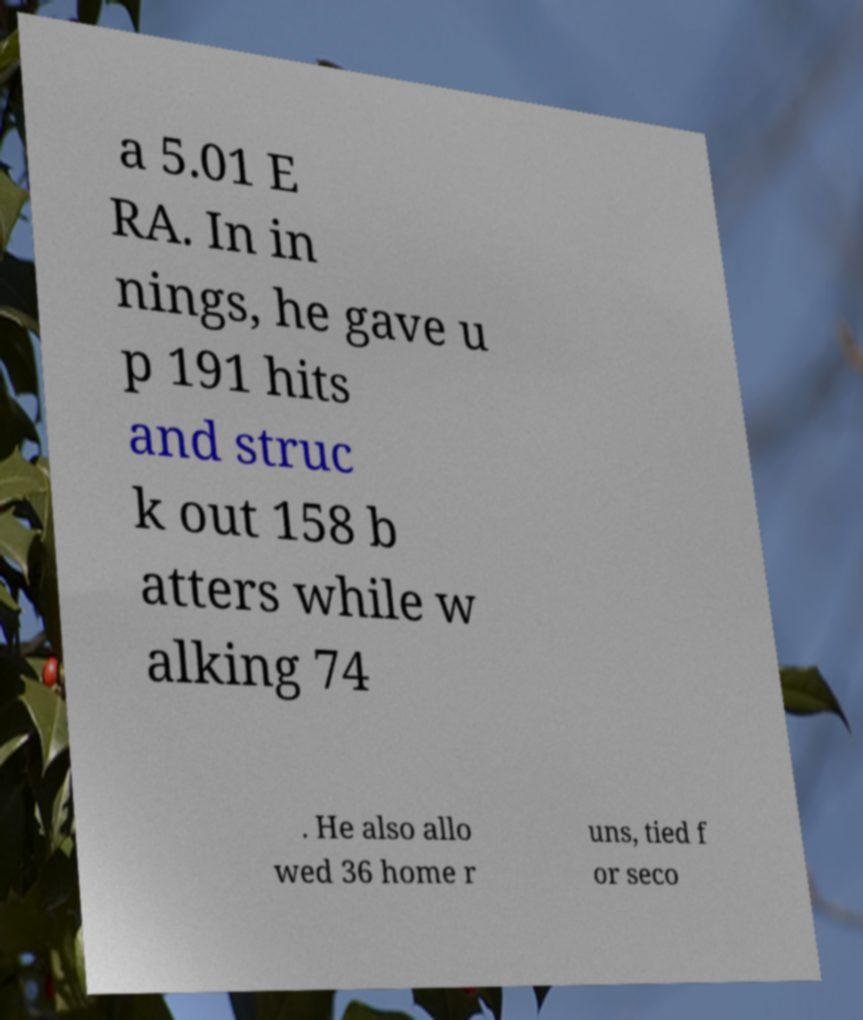There's text embedded in this image that I need extracted. Can you transcribe it verbatim? a 5.01 E RA. In in nings, he gave u p 191 hits and struc k out 158 b atters while w alking 74 . He also allo wed 36 home r uns, tied f or seco 